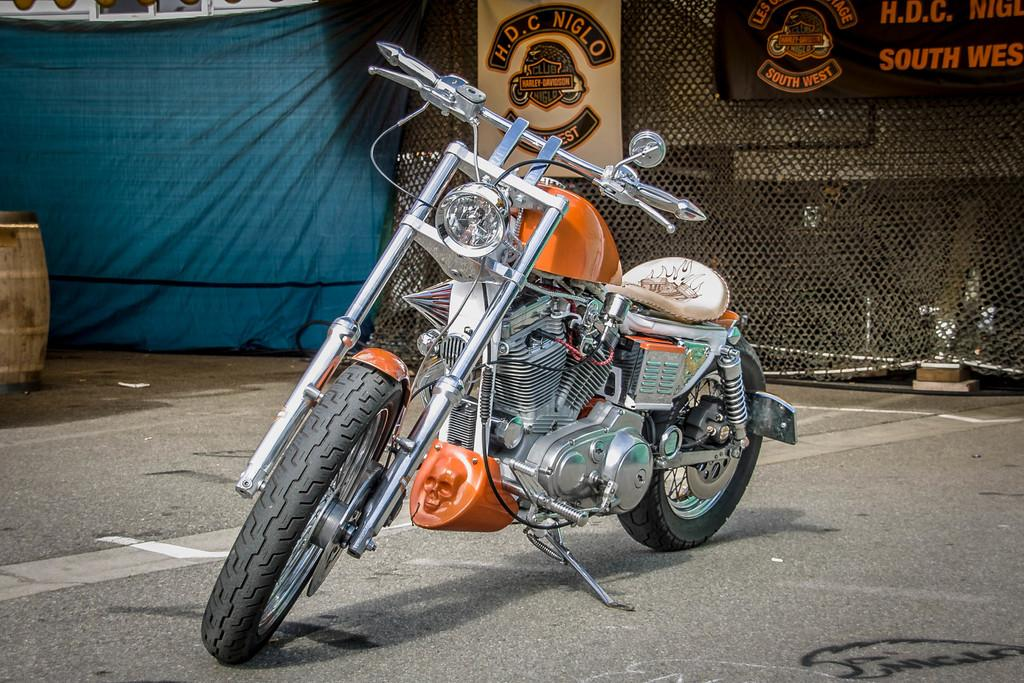What is the main subject of the image? The main subject of the image is a bike. Where is the bike located in the image? The bike is on a road in the image. What can be seen in the background of the image? There is a net and a cloth in the background of the image. What is written or displayed on the net or cloth? There is text and a logo on the net or cloth in the image. Can you see a window in the image? There is no window present in the image; it features a bike on a road with a net and a cloth in the background. 